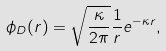Convert formula to latex. <formula><loc_0><loc_0><loc_500><loc_500>\phi _ { D } ( r ) = \sqrt { \frac { \kappa } { 2 \pi } } \frac { 1 } { r } e ^ { - \kappa r } ,</formula> 